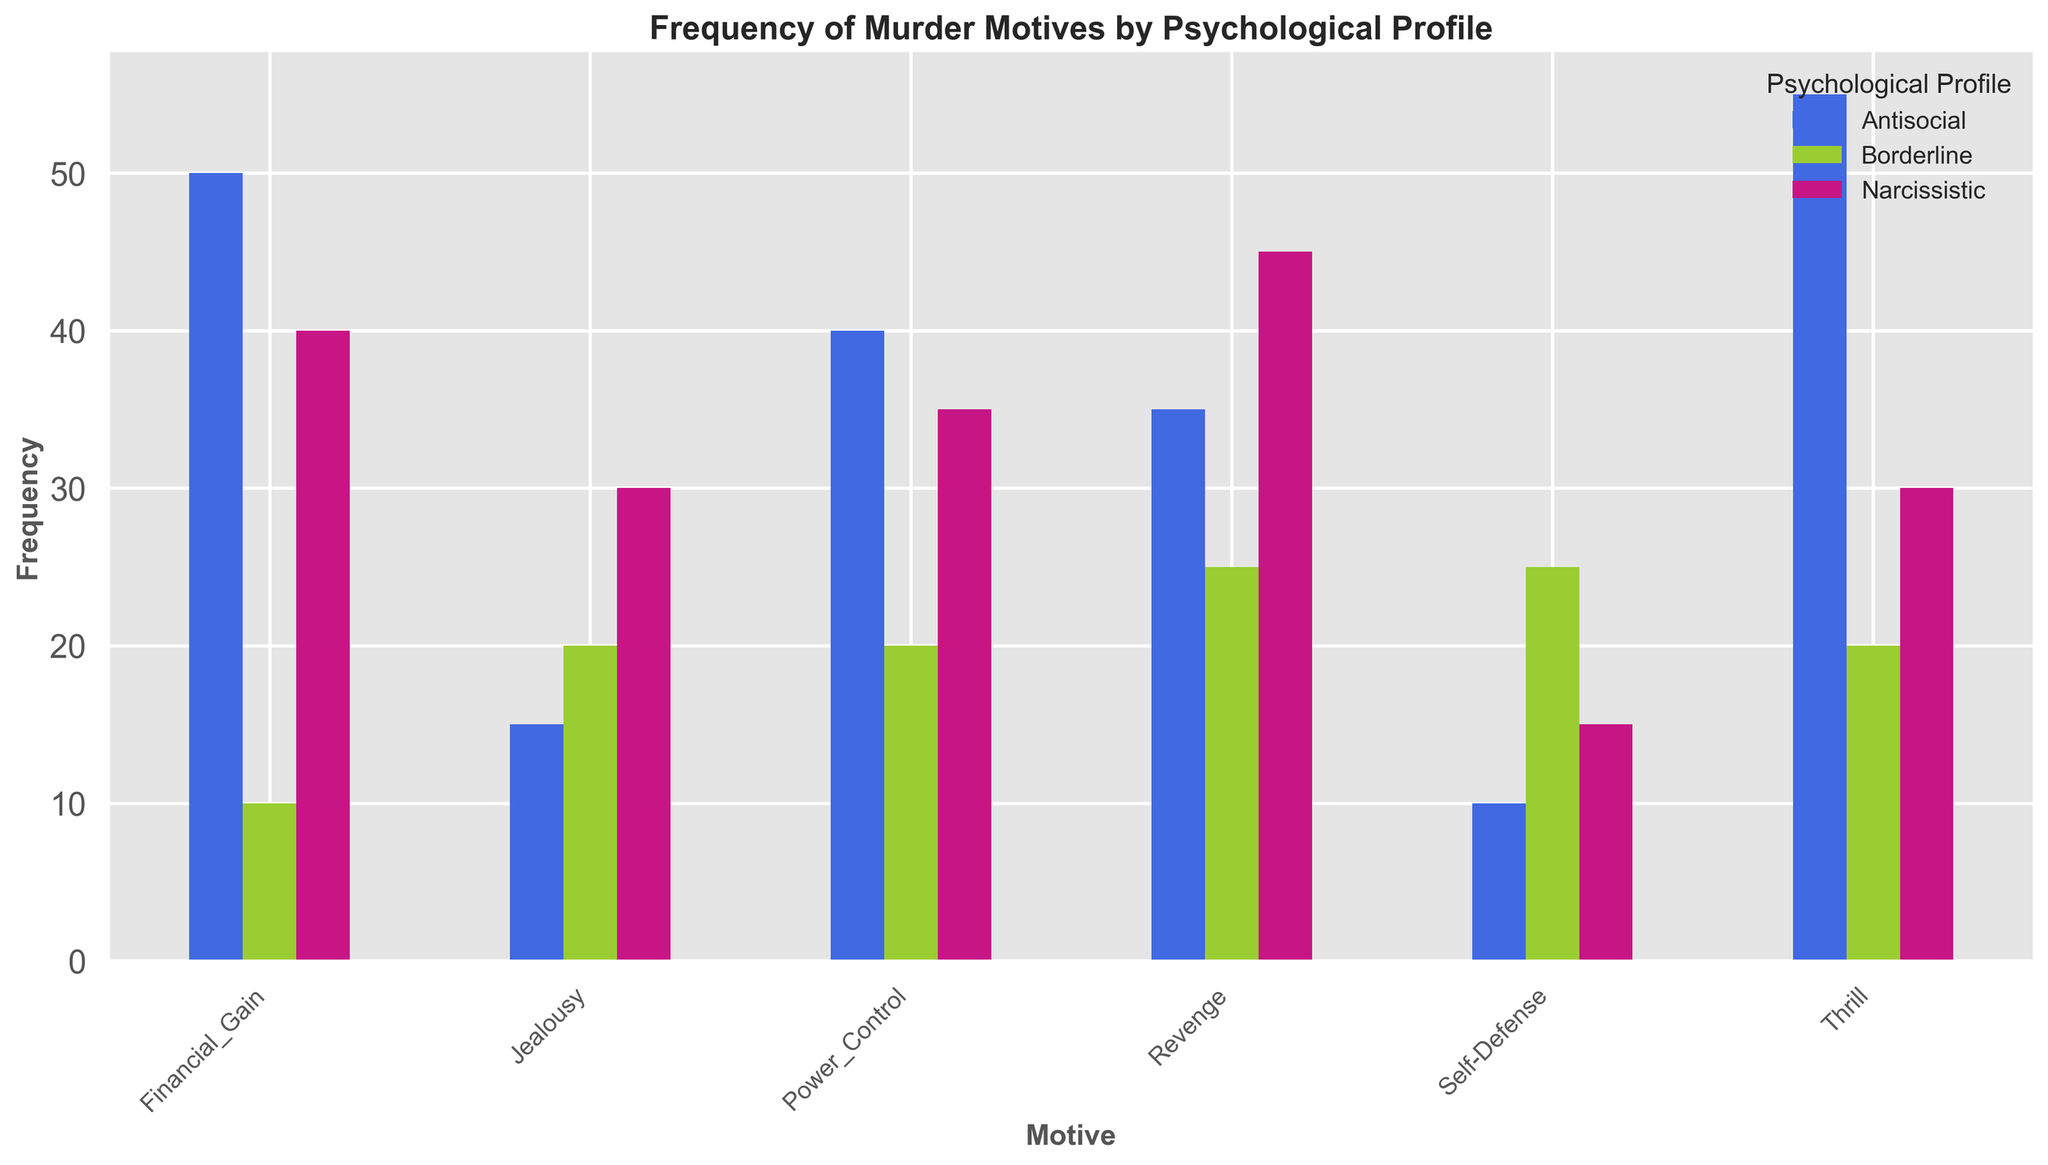Which psychological profile has the highest frequency for the motive "Thrill"? Observe the heights of the bars for the "Thrill" motive. The highest bar corresponds to the Antisocial profile, which has a frequency of 55.
Answer: Antisocial What is the total frequency of the "Revenge" motive across all psychological profiles? Sum the frequencies of the "Revenge" motive for all profiles: (45 for Narcissistic) + (35 for Antisocial) + (25 for Borderline) = 105.
Answer: 105 Which motive has the highest total frequency across all psychological profiles? Sum the frequencies for each motive and compare: 
- Revenge: 105
- Jealousy: 65
- Financial Gain: 100
- Thrill: 105
- Self-Defense: 50
- Power Control: 95
"Revenge" and "Thrill" both have the highest total frequency of 105.
Answer: Revenge and Thrill How does the frequency for "Financial Gain" compare between the Antisocial and Borderline profiles? Observe the heights of the bars for "Financial Gain". The Antisocial profile has a height of 50, and the Borderline profile has a height of 10. 50 is greater than 10.
Answer: Antisocial is higher Which motive has the lowest frequency for the Narcissistic profile? Observe the heights of the bars for the Narcissistic profile. The lowest bar corresponds to the "Self-Defense" motive, which has a frequency of 15.
Answer: Self-Defense What is the combined frequency for "Power Control" and "Jealousy" under the Borderline profile? Add the frequencies of the "Power Control" and "Jealousy" motives for the Borderline profile: (20 for Power Control) + (20 for Jealousy) = 40.
Answer: 40 Is the sum of frequencies for the "Self-Defense" motive less than the frequency for the "Thrill" motive in one psychological profile? Calculate the total frequency for "Self-Defense" (25 for Borderline + 15 for Narcissistic + 10 for Antisocial = 50) and compare with the "Thrill" frequency in the Antisocial profile (55). 50 is less than 55.
Answer: Yes Among Narcissistic individuals, which motive has a higher frequency: "Financial Gain" or "Jealousy"? Compare the heights of the bars for "Financial Gain" and "Jealousy" in the Narcissistic profile. "Financial Gain" has a frequency of 40, which is higher than "Jealousy" with a frequency of 30.
Answer: Financial Gain What is the difference in frequency between "Power Control" and "Revenge" motives for the Narcissistic profile? Subtract the frequency for "Revenge" from "Power Control" in the Narcissistic profile: 35 (Power Control) - 45 (Revenge) = -10.
Answer: -10 